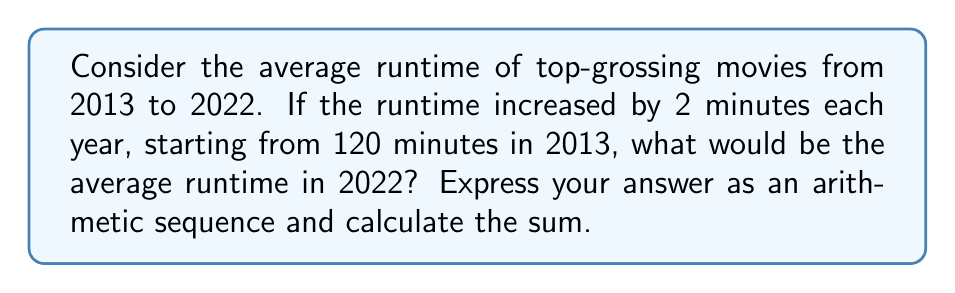What is the answer to this math problem? Let's approach this step-by-step:

1) We're dealing with an arithmetic sequence where:
   - The first term $a_1 = 120$ (runtime in 2013)
   - The common difference $d = 2$ (increase per year)
   - We need to find the 10th term (2022 is 10 years from 2013)

2) The formula for the nth term of an arithmetic sequence is:
   $a_n = a_1 + (n-1)d$

3) For 2022 (the 10th term):
   $a_{10} = 120 + (10-1)2$
   $a_{10} = 120 + 18 = 138$

4) The average runtime in 2022 would be 138 minutes.

5) To express this as an arithmetic sequence:
   $a_n = 120 + (n-1)2$, where $n$ is the number of years since 2013

6) The sum of this arithmetic sequence from 2013 to 2022 can be calculated using the formula:
   $S_n = \frac{n}{2}(a_1 + a_n)$, where $n = 10$

7) Substituting the values:
   $S_{10} = \frac{10}{2}(120 + 138)$
   $S_{10} = 5(258) = 1290$

Thus, the sum of all runtimes from 2013 to 2022 would be 1290 minutes.
Answer: $a_n = 120 + (n-1)2$; Sum = 1290 minutes 